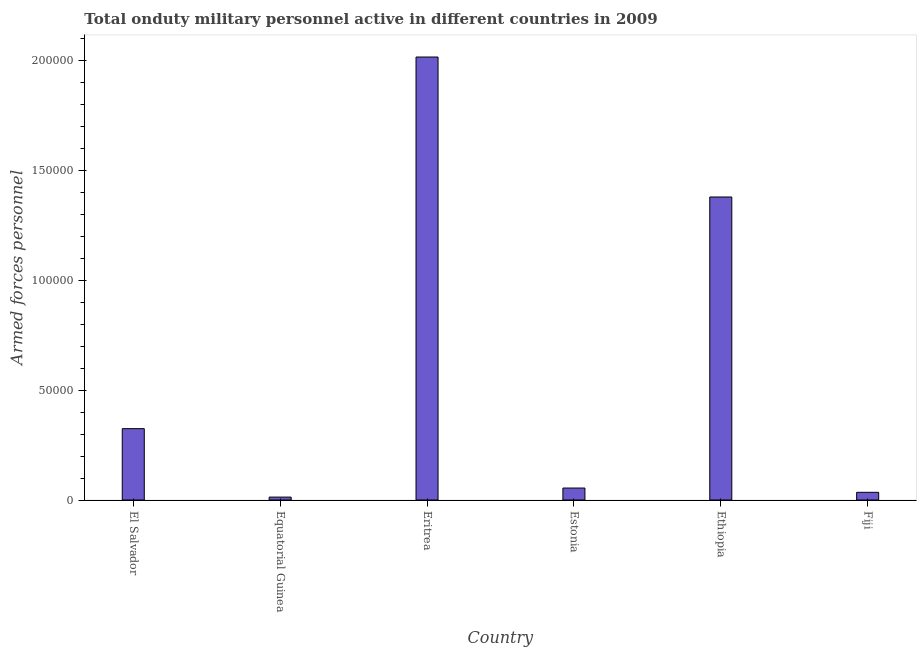Does the graph contain any zero values?
Offer a very short reply. No. Does the graph contain grids?
Ensure brevity in your answer.  No. What is the title of the graph?
Ensure brevity in your answer.  Total onduty military personnel active in different countries in 2009. What is the label or title of the X-axis?
Offer a very short reply. Country. What is the label or title of the Y-axis?
Your response must be concise. Armed forces personnel. What is the number of armed forces personnel in Eritrea?
Offer a terse response. 2.02e+05. Across all countries, what is the maximum number of armed forces personnel?
Keep it short and to the point. 2.02e+05. Across all countries, what is the minimum number of armed forces personnel?
Offer a terse response. 1320. In which country was the number of armed forces personnel maximum?
Provide a succinct answer. Eritrea. In which country was the number of armed forces personnel minimum?
Offer a terse response. Equatorial Guinea. What is the sum of the number of armed forces personnel?
Your answer should be compact. 3.83e+05. What is the difference between the number of armed forces personnel in El Salvador and Fiji?
Your response must be concise. 2.90e+04. What is the average number of armed forces personnel per country?
Offer a terse response. 6.38e+04. What is the median number of armed forces personnel?
Offer a terse response. 1.90e+04. Is the number of armed forces personnel in El Salvador less than that in Ethiopia?
Give a very brief answer. Yes. What is the difference between the highest and the second highest number of armed forces personnel?
Offer a terse response. 6.38e+04. What is the difference between the highest and the lowest number of armed forces personnel?
Keep it short and to the point. 2.00e+05. What is the difference between two consecutive major ticks on the Y-axis?
Your answer should be very brief. 5.00e+04. What is the Armed forces personnel in El Salvador?
Offer a very short reply. 3.25e+04. What is the Armed forces personnel of Equatorial Guinea?
Offer a terse response. 1320. What is the Armed forces personnel in Eritrea?
Keep it short and to the point. 2.02e+05. What is the Armed forces personnel of Estonia?
Provide a short and direct response. 5450. What is the Armed forces personnel of Ethiopia?
Your answer should be very brief. 1.38e+05. What is the Armed forces personnel in Fiji?
Give a very brief answer. 3500. What is the difference between the Armed forces personnel in El Salvador and Equatorial Guinea?
Make the answer very short. 3.12e+04. What is the difference between the Armed forces personnel in El Salvador and Eritrea?
Make the answer very short. -1.69e+05. What is the difference between the Armed forces personnel in El Salvador and Estonia?
Make the answer very short. 2.70e+04. What is the difference between the Armed forces personnel in El Salvador and Ethiopia?
Give a very brief answer. -1.06e+05. What is the difference between the Armed forces personnel in El Salvador and Fiji?
Your answer should be compact. 2.90e+04. What is the difference between the Armed forces personnel in Equatorial Guinea and Eritrea?
Provide a short and direct response. -2.00e+05. What is the difference between the Armed forces personnel in Equatorial Guinea and Estonia?
Keep it short and to the point. -4130. What is the difference between the Armed forces personnel in Equatorial Guinea and Ethiopia?
Offer a very short reply. -1.37e+05. What is the difference between the Armed forces personnel in Equatorial Guinea and Fiji?
Ensure brevity in your answer.  -2180. What is the difference between the Armed forces personnel in Eritrea and Estonia?
Make the answer very short. 1.96e+05. What is the difference between the Armed forces personnel in Eritrea and Ethiopia?
Make the answer very short. 6.38e+04. What is the difference between the Armed forces personnel in Eritrea and Fiji?
Keep it short and to the point. 1.98e+05. What is the difference between the Armed forces personnel in Estonia and Ethiopia?
Make the answer very short. -1.33e+05. What is the difference between the Armed forces personnel in Estonia and Fiji?
Provide a succinct answer. 1950. What is the difference between the Armed forces personnel in Ethiopia and Fiji?
Provide a short and direct response. 1.34e+05. What is the ratio of the Armed forces personnel in El Salvador to that in Equatorial Guinea?
Give a very brief answer. 24.62. What is the ratio of the Armed forces personnel in El Salvador to that in Eritrea?
Your answer should be very brief. 0.16. What is the ratio of the Armed forces personnel in El Salvador to that in Estonia?
Keep it short and to the point. 5.96. What is the ratio of the Armed forces personnel in El Salvador to that in Ethiopia?
Provide a succinct answer. 0.24. What is the ratio of the Armed forces personnel in El Salvador to that in Fiji?
Offer a terse response. 9.29. What is the ratio of the Armed forces personnel in Equatorial Guinea to that in Eritrea?
Your response must be concise. 0.01. What is the ratio of the Armed forces personnel in Equatorial Guinea to that in Estonia?
Offer a terse response. 0.24. What is the ratio of the Armed forces personnel in Equatorial Guinea to that in Ethiopia?
Provide a succinct answer. 0.01. What is the ratio of the Armed forces personnel in Equatorial Guinea to that in Fiji?
Your response must be concise. 0.38. What is the ratio of the Armed forces personnel in Eritrea to that in Estonia?
Ensure brevity in your answer.  37.02. What is the ratio of the Armed forces personnel in Eritrea to that in Ethiopia?
Give a very brief answer. 1.46. What is the ratio of the Armed forces personnel in Eritrea to that in Fiji?
Your answer should be very brief. 57.64. What is the ratio of the Armed forces personnel in Estonia to that in Ethiopia?
Offer a terse response. 0.04. What is the ratio of the Armed forces personnel in Estonia to that in Fiji?
Provide a succinct answer. 1.56. What is the ratio of the Armed forces personnel in Ethiopia to that in Fiji?
Offer a terse response. 39.43. 